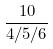Convert formula to latex. <formula><loc_0><loc_0><loc_500><loc_500>\frac { 1 0 } { 4 / 5 / 6 }</formula> 